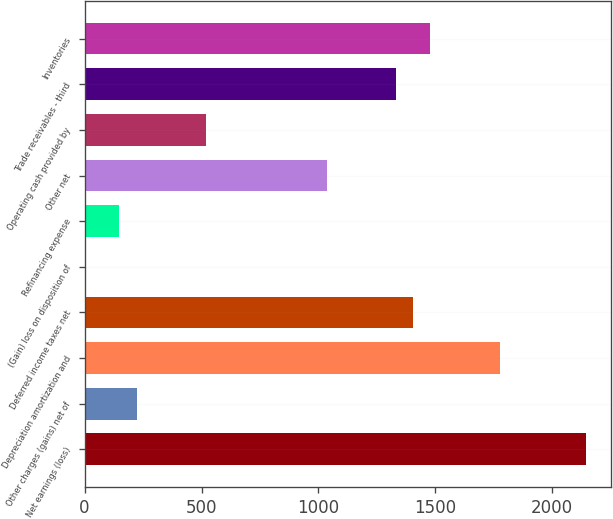<chart> <loc_0><loc_0><loc_500><loc_500><bar_chart><fcel>Net earnings (loss)<fcel>Other charges (gains) net of<fcel>Depreciation amortization and<fcel>Deferred income taxes net<fcel>(Gain) loss on disposition of<fcel>Refinancing expense<fcel>Other net<fcel>Operating cash provided by<fcel>Trade receivables - third<fcel>Inventories<nl><fcel>2144.1<fcel>222.7<fcel>1774.6<fcel>1405.1<fcel>1<fcel>148.8<fcel>1035.6<fcel>518.3<fcel>1331.2<fcel>1479<nl></chart> 